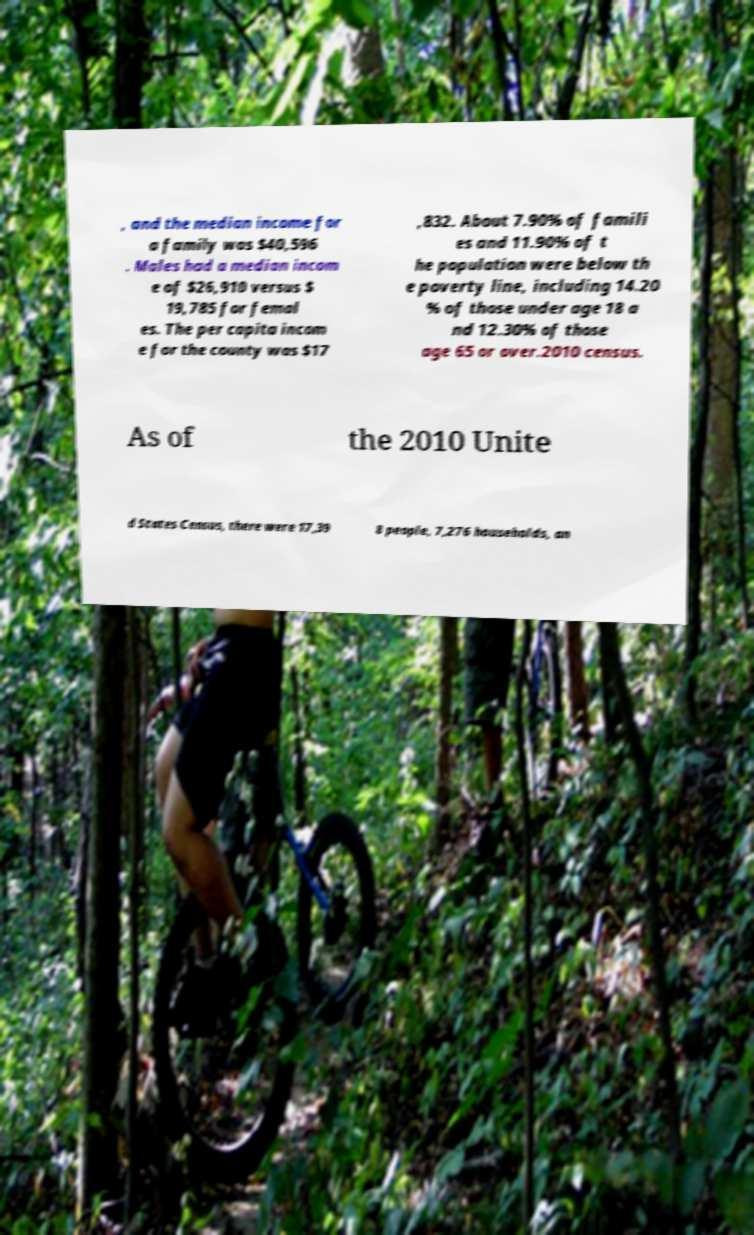I need the written content from this picture converted into text. Can you do that? , and the median income for a family was $40,596 . Males had a median incom e of $26,910 versus $ 19,785 for femal es. The per capita incom e for the county was $17 ,832. About 7.90% of famili es and 11.90% of t he population were below th e poverty line, including 14.20 % of those under age 18 a nd 12.30% of those age 65 or over.2010 census. As of the 2010 Unite d States Census, there were 17,39 8 people, 7,276 households, an 